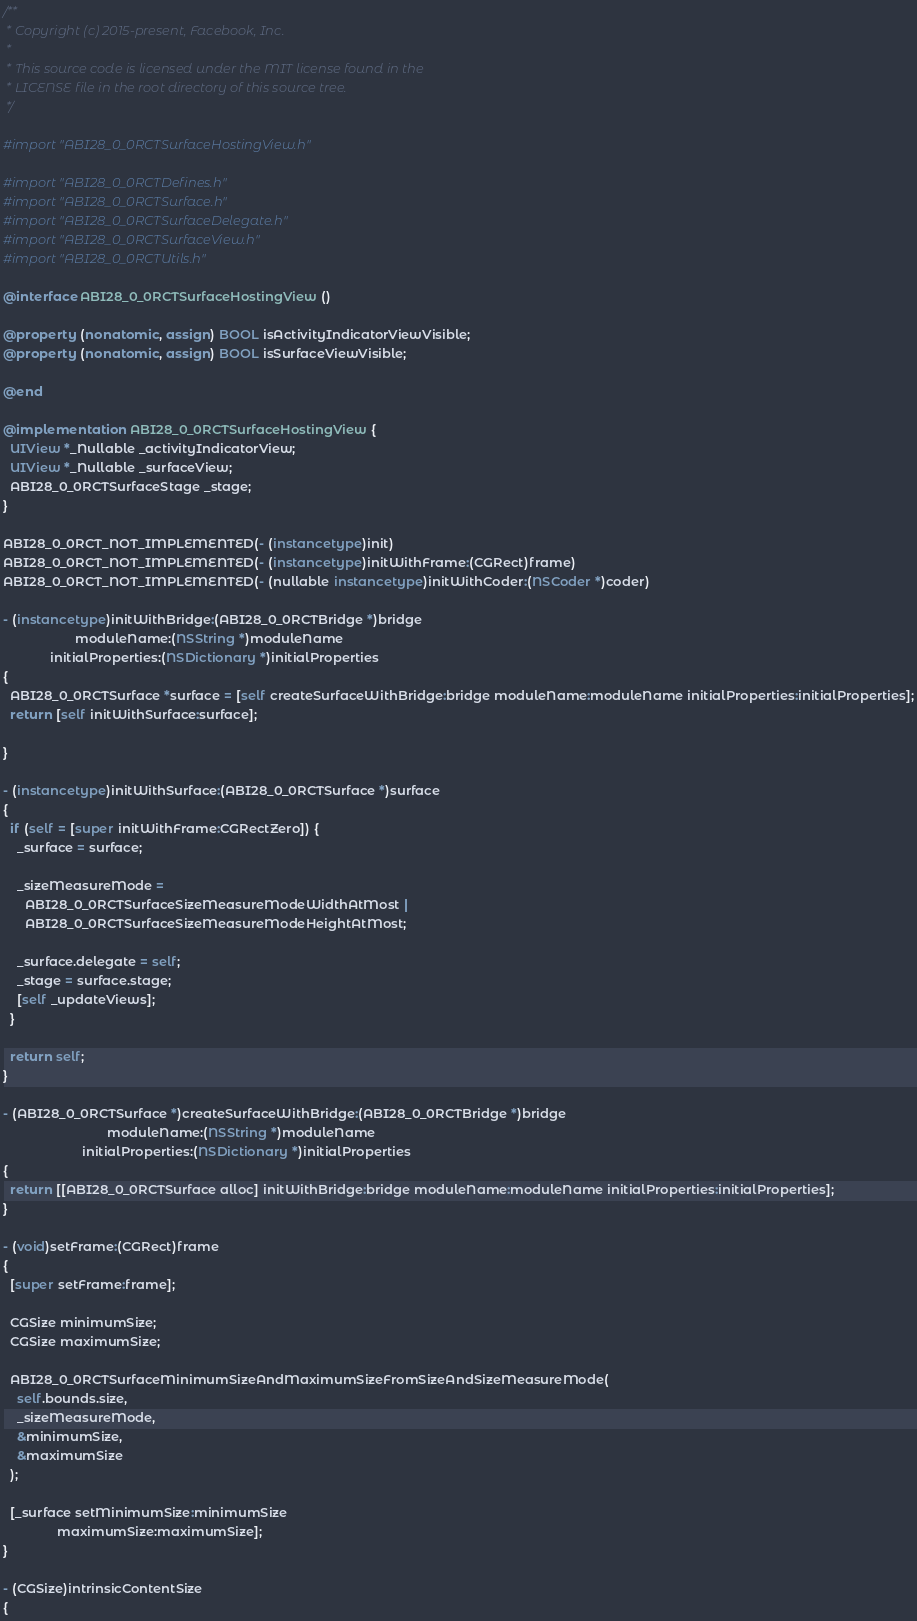Convert code to text. <code><loc_0><loc_0><loc_500><loc_500><_ObjectiveC_>/**
 * Copyright (c) 2015-present, Facebook, Inc.
 *
 * This source code is licensed under the MIT license found in the
 * LICENSE file in the root directory of this source tree.
 */

#import "ABI28_0_0RCTSurfaceHostingView.h"

#import "ABI28_0_0RCTDefines.h"
#import "ABI28_0_0RCTSurface.h"
#import "ABI28_0_0RCTSurfaceDelegate.h"
#import "ABI28_0_0RCTSurfaceView.h"
#import "ABI28_0_0RCTUtils.h"

@interface ABI28_0_0RCTSurfaceHostingView ()

@property (nonatomic, assign) BOOL isActivityIndicatorViewVisible;
@property (nonatomic, assign) BOOL isSurfaceViewVisible;

@end

@implementation ABI28_0_0RCTSurfaceHostingView {
  UIView *_Nullable _activityIndicatorView;
  UIView *_Nullable _surfaceView;
  ABI28_0_0RCTSurfaceStage _stage;
}

ABI28_0_0RCT_NOT_IMPLEMENTED(- (instancetype)init)
ABI28_0_0RCT_NOT_IMPLEMENTED(- (instancetype)initWithFrame:(CGRect)frame)
ABI28_0_0RCT_NOT_IMPLEMENTED(- (nullable instancetype)initWithCoder:(NSCoder *)coder)

- (instancetype)initWithBridge:(ABI28_0_0RCTBridge *)bridge
                    moduleName:(NSString *)moduleName
             initialProperties:(NSDictionary *)initialProperties
{
  ABI28_0_0RCTSurface *surface = [self createSurfaceWithBridge:bridge moduleName:moduleName initialProperties:initialProperties];
  return [self initWithSurface:surface];

}

- (instancetype)initWithSurface:(ABI28_0_0RCTSurface *)surface
{
  if (self = [super initWithFrame:CGRectZero]) {
    _surface = surface;

    _sizeMeasureMode =
      ABI28_0_0RCTSurfaceSizeMeasureModeWidthAtMost |
      ABI28_0_0RCTSurfaceSizeMeasureModeHeightAtMost;

    _surface.delegate = self;
    _stage = surface.stage;
    [self _updateViews];
  }

  return self;
}

- (ABI28_0_0RCTSurface *)createSurfaceWithBridge:(ABI28_0_0RCTBridge *)bridge
                             moduleName:(NSString *)moduleName
                      initialProperties:(NSDictionary *)initialProperties
{
  return [[ABI28_0_0RCTSurface alloc] initWithBridge:bridge moduleName:moduleName initialProperties:initialProperties];
}

- (void)setFrame:(CGRect)frame
{
  [super setFrame:frame];

  CGSize minimumSize;
  CGSize maximumSize;

  ABI28_0_0RCTSurfaceMinimumSizeAndMaximumSizeFromSizeAndSizeMeasureMode(
    self.bounds.size,
    _sizeMeasureMode,
    &minimumSize,
    &maximumSize
  );

  [_surface setMinimumSize:minimumSize
               maximumSize:maximumSize];
}

- (CGSize)intrinsicContentSize
{</code> 